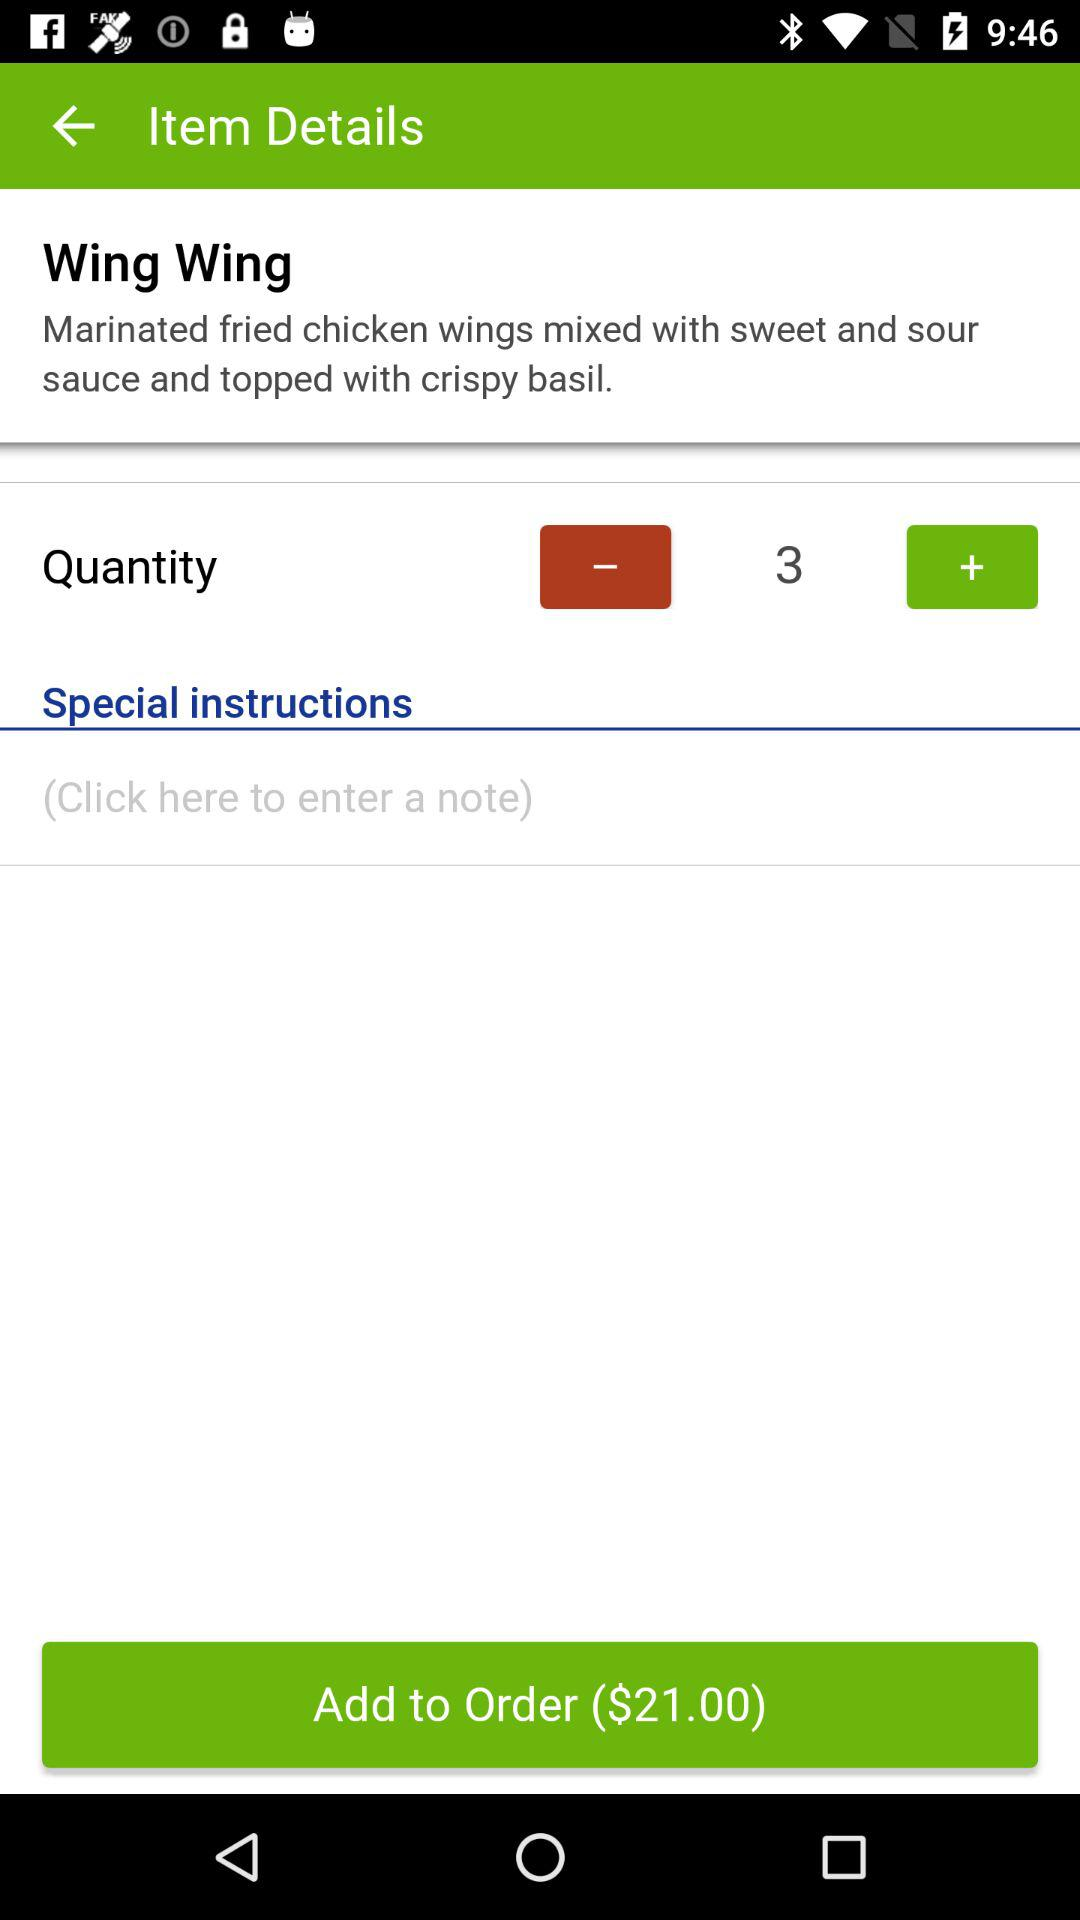What is the quantity? The quantity is 3. 